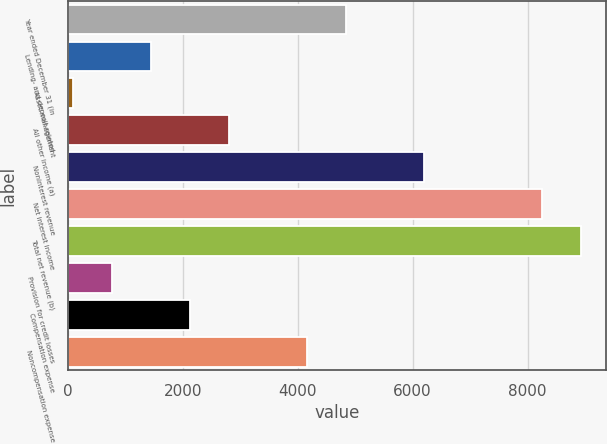<chart> <loc_0><loc_0><loc_500><loc_500><bar_chart><fcel>Year ended December 31 (in<fcel>Lending- and deposit-related<fcel>Asset management<fcel>All other income (a)<fcel>Noninterest revenue<fcel>Net interest income<fcel>Total net revenue (b)<fcel>Provision for credit losses<fcel>Compensation expense<fcel>Noncompensation expense<nl><fcel>4845.9<fcel>1447.4<fcel>88<fcel>2806.8<fcel>6205.3<fcel>8244.4<fcel>8924.1<fcel>767.7<fcel>2127.1<fcel>4166.2<nl></chart> 